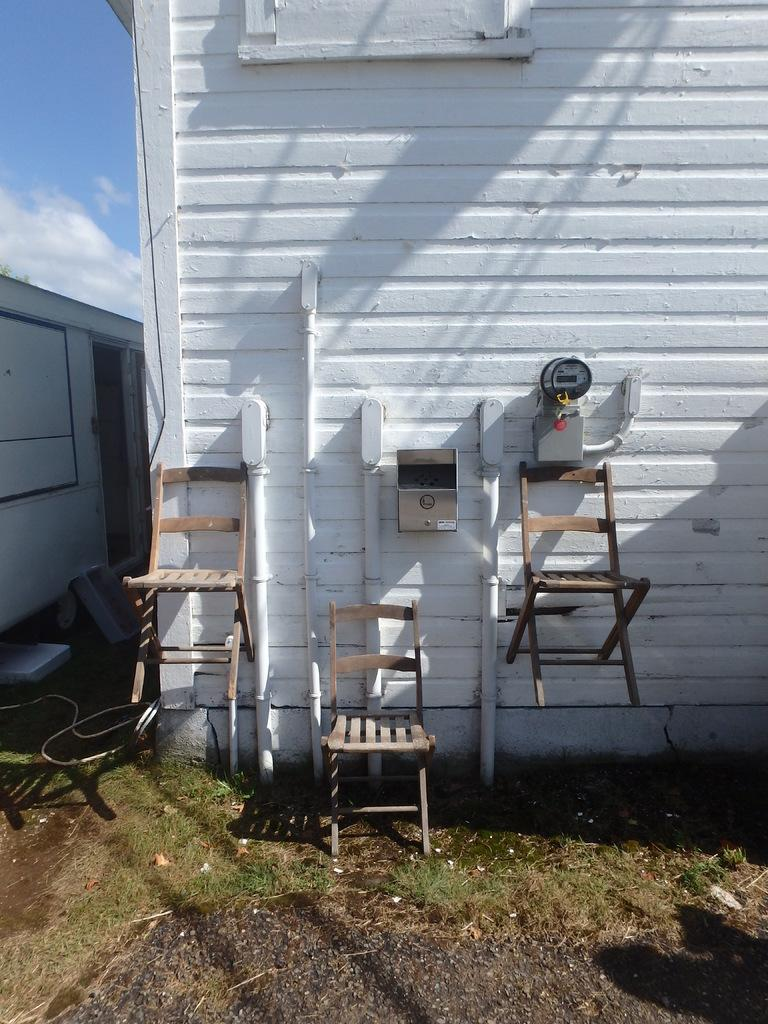What is the main subject in the center of the image? There is a vehicle in the center of the image. What type of structure can be seen in the image? There is a wall in the image. What are the pipes used for in the image? The pipes are present in the image, but their purpose is not specified. What is the purpose of the meter in the image? A meter is visible in the image, but its function is not clear. What is the box used for in the image? The purpose of the box in the image is not specified. How many wooden chairs are in the image? There are three wooden chairs in the image. What type of natural environment is present in the image? Grass is present in the image. What is visible in the background of the image? The sky and clouds are visible in the background of the image. What type of language is spoken by the tomatoes in the image? There are no tomatoes present in the image, so it is not possible to determine what language they might speak. 